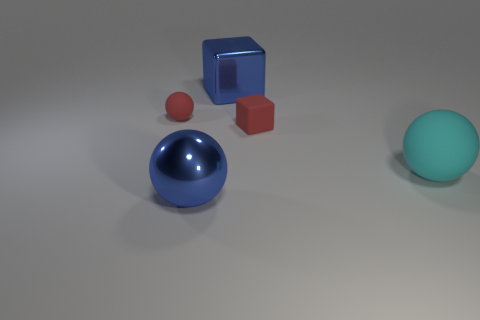Add 1 matte spheres. How many objects exist? 6 Subtract all cubes. How many objects are left? 3 Add 3 red rubber cubes. How many red rubber cubes are left? 4 Add 3 big blue shiny spheres. How many big blue shiny spheres exist? 4 Subtract 0 gray balls. How many objects are left? 5 Subtract all large blue metal things. Subtract all metallic things. How many objects are left? 1 